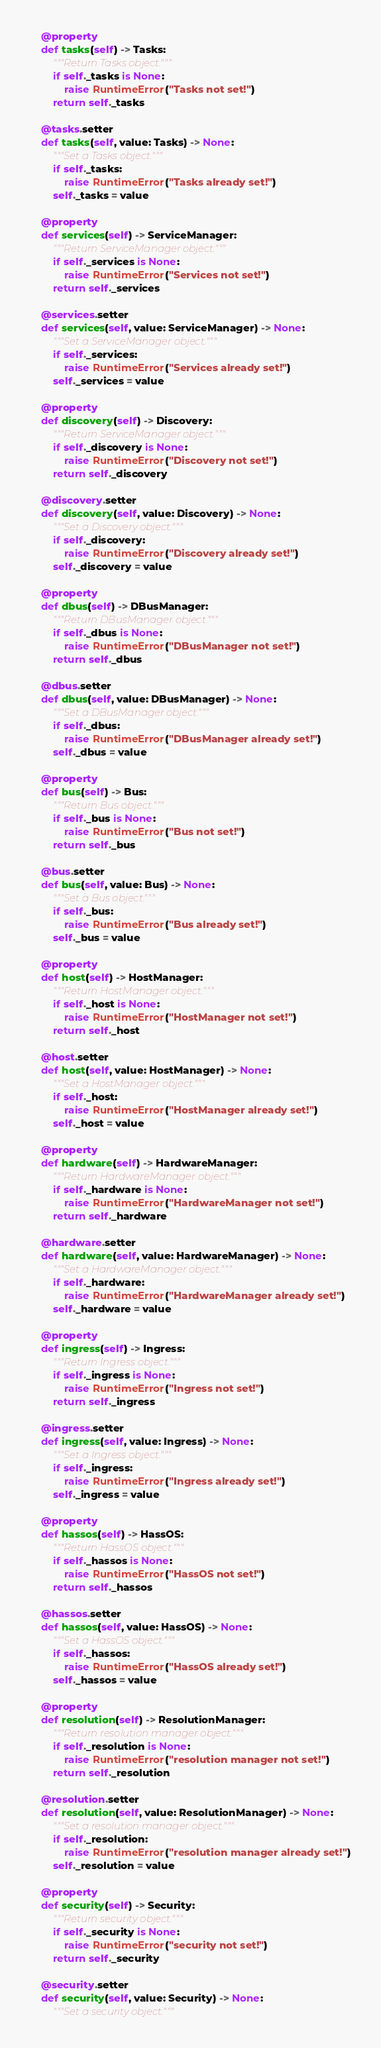Convert code to text. <code><loc_0><loc_0><loc_500><loc_500><_Python_>    @property
    def tasks(self) -> Tasks:
        """Return Tasks object."""
        if self._tasks is None:
            raise RuntimeError("Tasks not set!")
        return self._tasks

    @tasks.setter
    def tasks(self, value: Tasks) -> None:
        """Set a Tasks object."""
        if self._tasks:
            raise RuntimeError("Tasks already set!")
        self._tasks = value

    @property
    def services(self) -> ServiceManager:
        """Return ServiceManager object."""
        if self._services is None:
            raise RuntimeError("Services not set!")
        return self._services

    @services.setter
    def services(self, value: ServiceManager) -> None:
        """Set a ServiceManager object."""
        if self._services:
            raise RuntimeError("Services already set!")
        self._services = value

    @property
    def discovery(self) -> Discovery:
        """Return ServiceManager object."""
        if self._discovery is None:
            raise RuntimeError("Discovery not set!")
        return self._discovery

    @discovery.setter
    def discovery(self, value: Discovery) -> None:
        """Set a Discovery object."""
        if self._discovery:
            raise RuntimeError("Discovery already set!")
        self._discovery = value

    @property
    def dbus(self) -> DBusManager:
        """Return DBusManager object."""
        if self._dbus is None:
            raise RuntimeError("DBusManager not set!")
        return self._dbus

    @dbus.setter
    def dbus(self, value: DBusManager) -> None:
        """Set a DBusManager object."""
        if self._dbus:
            raise RuntimeError("DBusManager already set!")
        self._dbus = value

    @property
    def bus(self) -> Bus:
        """Return Bus object."""
        if self._bus is None:
            raise RuntimeError("Bus not set!")
        return self._bus

    @bus.setter
    def bus(self, value: Bus) -> None:
        """Set a Bus object."""
        if self._bus:
            raise RuntimeError("Bus already set!")
        self._bus = value

    @property
    def host(self) -> HostManager:
        """Return HostManager object."""
        if self._host is None:
            raise RuntimeError("HostManager not set!")
        return self._host

    @host.setter
    def host(self, value: HostManager) -> None:
        """Set a HostManager object."""
        if self._host:
            raise RuntimeError("HostManager already set!")
        self._host = value

    @property
    def hardware(self) -> HardwareManager:
        """Return HardwareManager object."""
        if self._hardware is None:
            raise RuntimeError("HardwareManager not set!")
        return self._hardware

    @hardware.setter
    def hardware(self, value: HardwareManager) -> None:
        """Set a HardwareManager object."""
        if self._hardware:
            raise RuntimeError("HardwareManager already set!")
        self._hardware = value

    @property
    def ingress(self) -> Ingress:
        """Return Ingress object."""
        if self._ingress is None:
            raise RuntimeError("Ingress not set!")
        return self._ingress

    @ingress.setter
    def ingress(self, value: Ingress) -> None:
        """Set a Ingress object."""
        if self._ingress:
            raise RuntimeError("Ingress already set!")
        self._ingress = value

    @property
    def hassos(self) -> HassOS:
        """Return HassOS object."""
        if self._hassos is None:
            raise RuntimeError("HassOS not set!")
        return self._hassos

    @hassos.setter
    def hassos(self, value: HassOS) -> None:
        """Set a HassOS object."""
        if self._hassos:
            raise RuntimeError("HassOS already set!")
        self._hassos = value

    @property
    def resolution(self) -> ResolutionManager:
        """Return resolution manager object."""
        if self._resolution is None:
            raise RuntimeError("resolution manager not set!")
        return self._resolution

    @resolution.setter
    def resolution(self, value: ResolutionManager) -> None:
        """Set a resolution manager object."""
        if self._resolution:
            raise RuntimeError("resolution manager already set!")
        self._resolution = value

    @property
    def security(self) -> Security:
        """Return security object."""
        if self._security is None:
            raise RuntimeError("security not set!")
        return self._security

    @security.setter
    def security(self, value: Security) -> None:
        """Set a security object."""</code> 